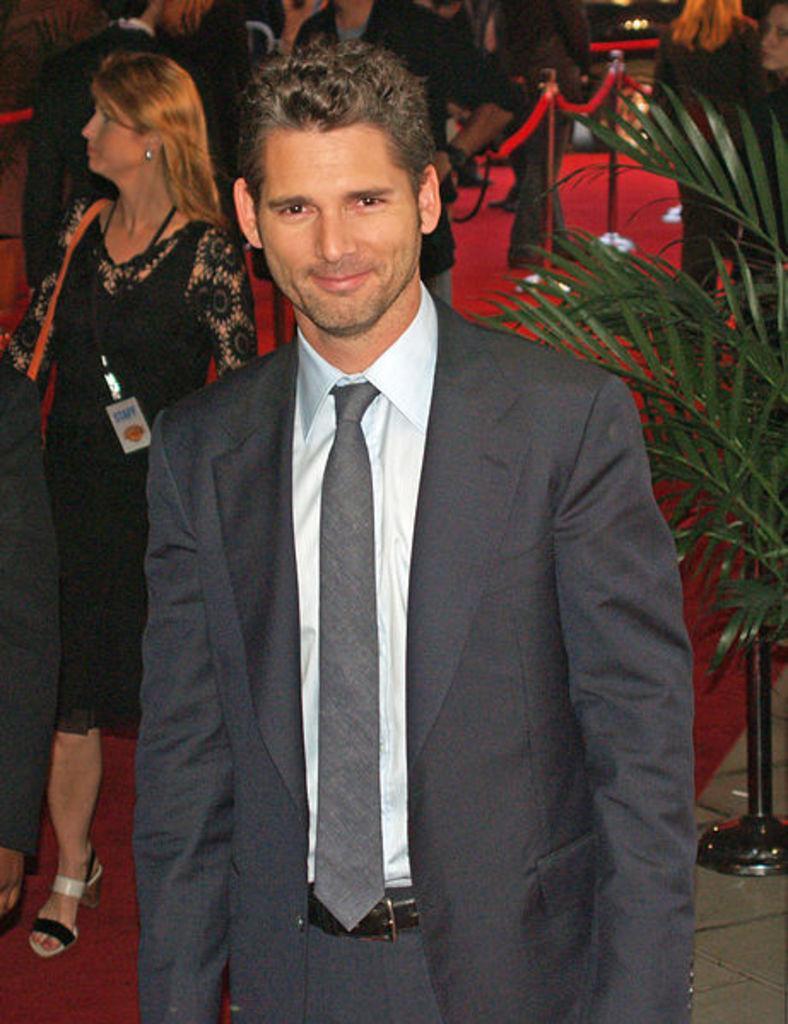How would you summarize this image in a sentence or two? In this image I can see people among them this man is standing and smiling. The man is wearing a suit. Here I can see a plant and red carpet. 